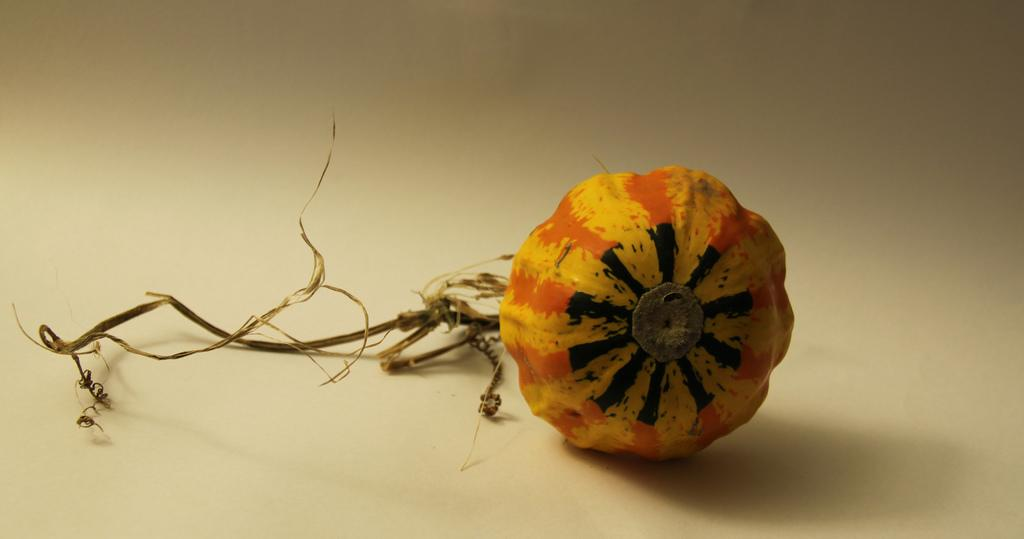What is the main object in the image? There is a pumpkin in the image. Where is the pumpkin located? The pumpkin is on a surface. What type of offer is being made with the vase in the image? There is no vase present in the image, and therefore no offer can be made with it. 